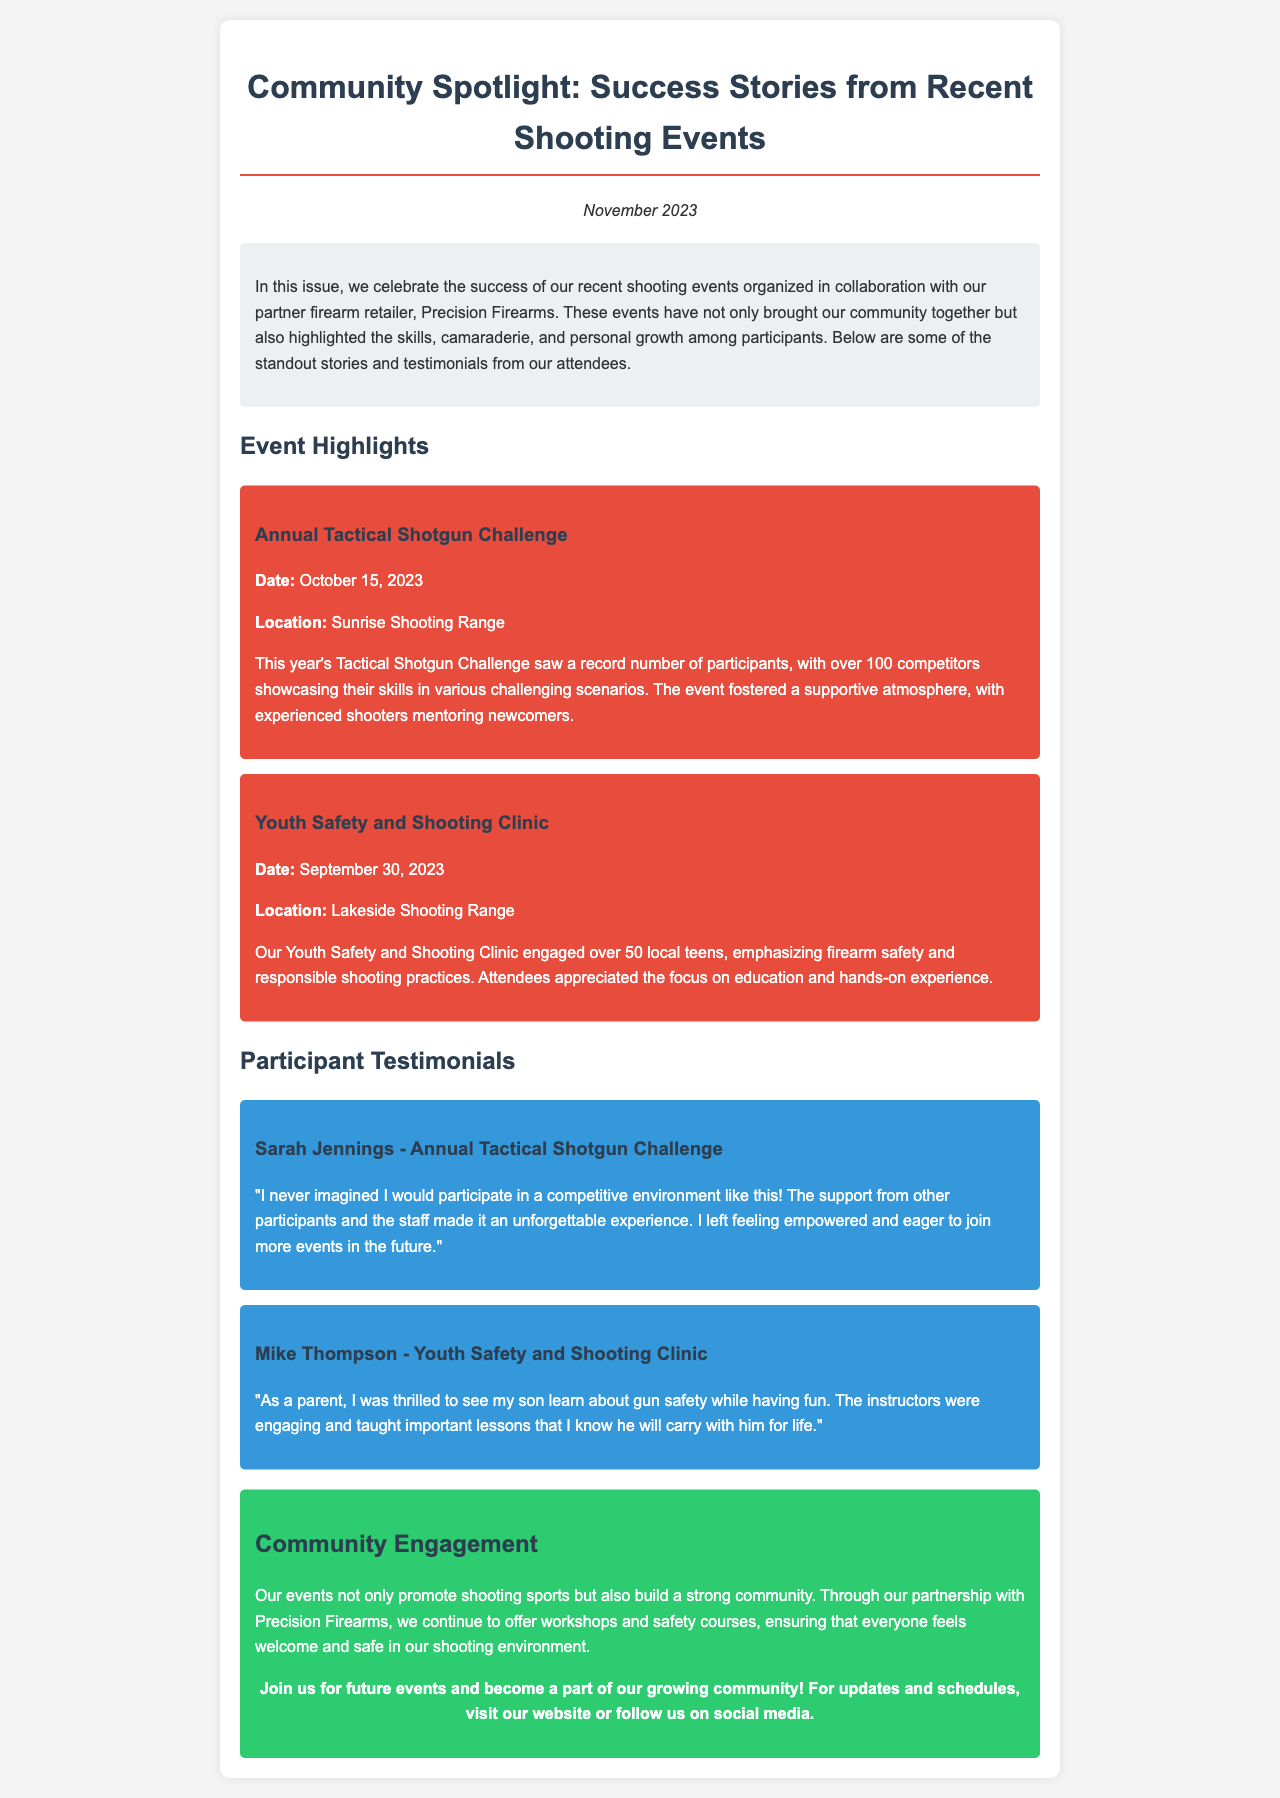What is the date of the Annual Tactical Shotgun Challenge? The document states that the Annual Tactical Shotgun Challenge occurred on October 15, 2023.
Answer: October 15, 2023 How many participants were there in the Youth Safety and Shooting Clinic? The document mentions that over 50 local teens engaged in the Youth Safety and Shooting Clinic.
Answer: over 50 Who is the partner firearm retailer mentioned in the newsletter? The newsletter highlights collaboration with Precision Firearms as the partner retailer.
Answer: Precision Firearms What atmosphere did the Tactical Shotgun Challenge foster? The document describes a supportive atmosphere where experienced shooters mentored newcomers.
Answer: supportive atmosphere What did Sarah Jennings feel after participating in the Tactical Shotgun Challenge? Sarah Jennings expressed that she felt empowered and eager to join more events in the future.
Answer: empowered What is the purpose of the community engagement described in the document? The document states that community engagement promotes shooting sports and builds a strong community through workshops and safety courses.
Answer: promote shooting sports and build community How many events are highlighted in the newsletter? The newsletter highlights two events: the Annual Tactical Shotgun Challenge and the Youth Safety and Shooting Clinic.
Answer: two events What was a key lesson that Mike Thompson appreciated from the clinic? Mike Thompson appreciated that the instructors taught important lessons about gun safety.
Answer: important lessons about gun safety 